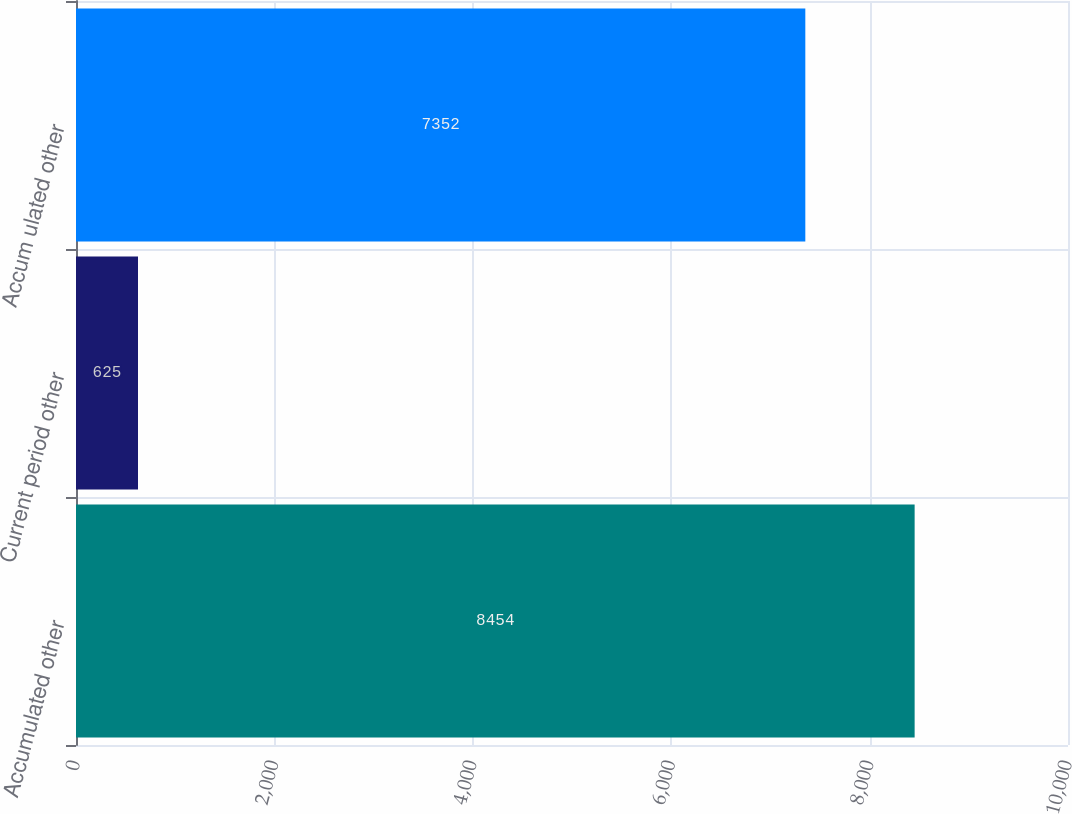Convert chart to OTSL. <chart><loc_0><loc_0><loc_500><loc_500><bar_chart><fcel>Accumulated other<fcel>Current period other<fcel>Accum ulated other<nl><fcel>8454<fcel>625<fcel>7352<nl></chart> 